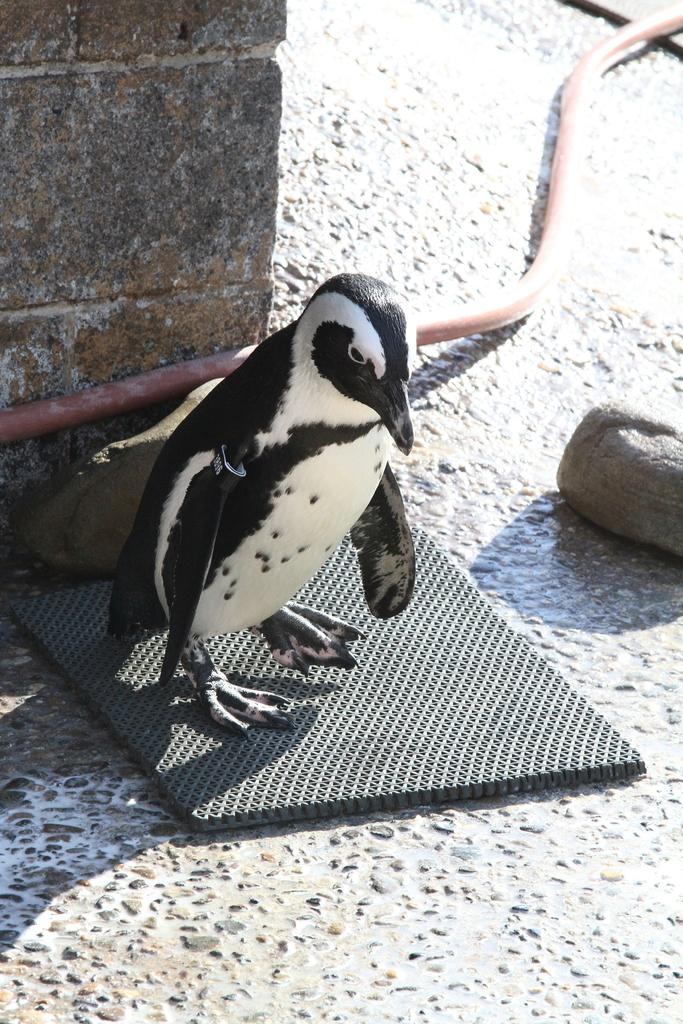What animal is present in the image? There is a penguin in the image. Where is the penguin located? The penguin is on a mat in the image. What can be seen in the background of the image? There is a wall in the image. What is the object on the ground in the image? There is a pipe on the ground in the image. What type of leather is visible on the penguin's eye in the image? There is no leather or eye present on the penguin in the image; it is a penguin standing on a mat. What kind of tent can be seen in the background of the image? There is no tent present in the image; it features a penguin on a mat with a wall in the background. 